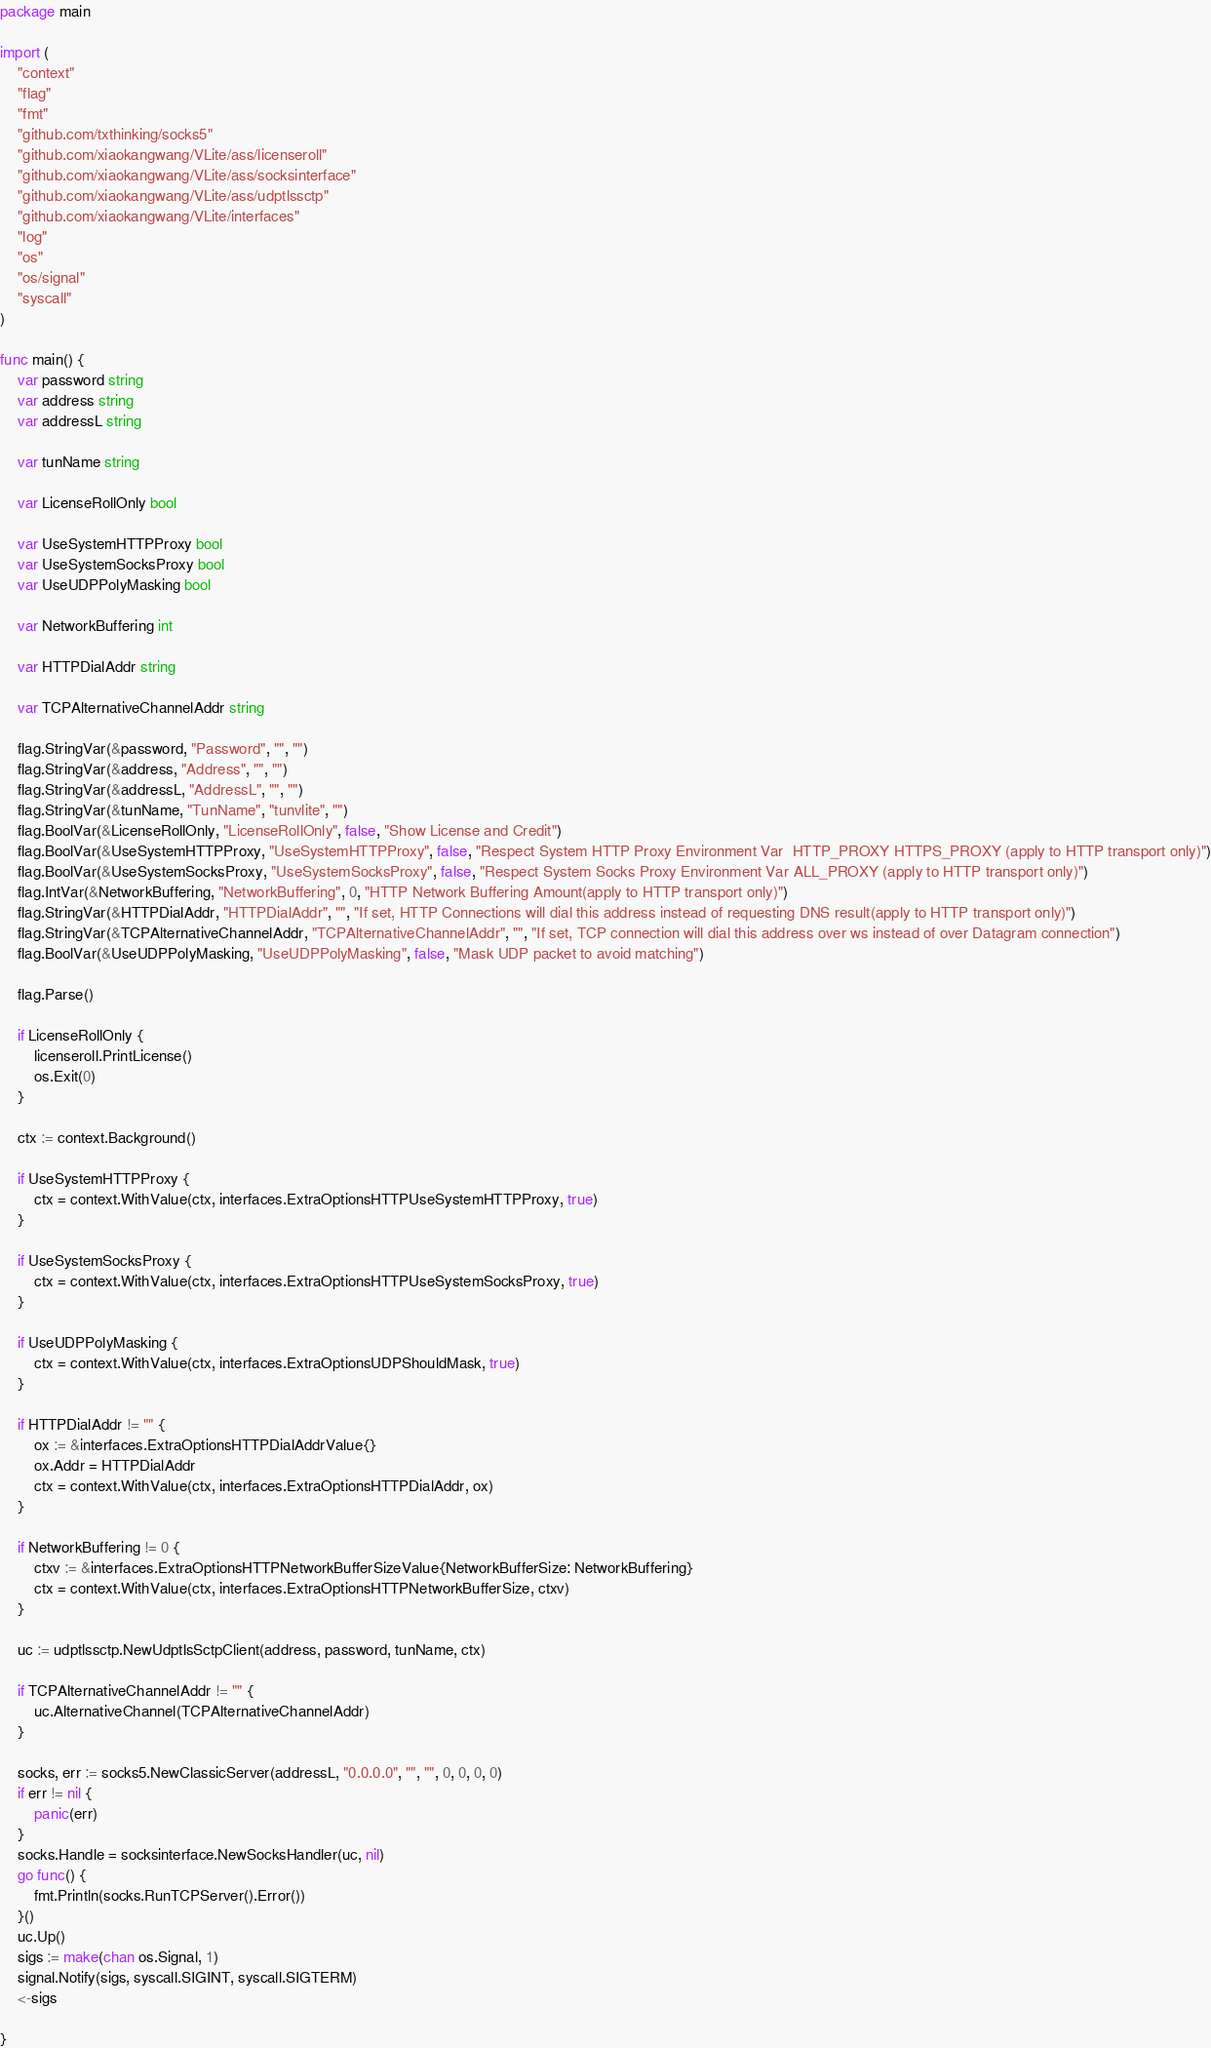<code> <loc_0><loc_0><loc_500><loc_500><_Go_>package main

import (
	"context"
	"flag"
	"fmt"
	"github.com/txthinking/socks5"
	"github.com/xiaokangwang/VLite/ass/licenseroll"
	"github.com/xiaokangwang/VLite/ass/socksinterface"
	"github.com/xiaokangwang/VLite/ass/udptlssctp"
	"github.com/xiaokangwang/VLite/interfaces"
	"log"
	"os"
	"os/signal"
	"syscall"
)

func main() {
	var password string
	var address string
	var addressL string

	var tunName string

	var LicenseRollOnly bool

	var UseSystemHTTPProxy bool
	var UseSystemSocksProxy bool
	var UseUDPPolyMasking bool

	var NetworkBuffering int

	var HTTPDialAddr string

	var TCPAlternativeChannelAddr string

	flag.StringVar(&password, "Password", "", "")
	flag.StringVar(&address, "Address", "", "")
	flag.StringVar(&addressL, "AddressL", "", "")
	flag.StringVar(&tunName, "TunName", "tunvlite", "")
	flag.BoolVar(&LicenseRollOnly, "LicenseRollOnly", false, "Show License and Credit")
	flag.BoolVar(&UseSystemHTTPProxy, "UseSystemHTTPProxy", false, "Respect System HTTP Proxy Environment Var  HTTP_PROXY HTTPS_PROXY (apply to HTTP transport only)")
	flag.BoolVar(&UseSystemSocksProxy, "UseSystemSocksProxy", false, "Respect System Socks Proxy Environment Var ALL_PROXY (apply to HTTP transport only)")
	flag.IntVar(&NetworkBuffering, "NetworkBuffering", 0, "HTTP Network Buffering Amount(apply to HTTP transport only)")
	flag.StringVar(&HTTPDialAddr, "HTTPDialAddr", "", "If set, HTTP Connections will dial this address instead of requesting DNS result(apply to HTTP transport only)")
	flag.StringVar(&TCPAlternativeChannelAddr, "TCPAlternativeChannelAddr", "", "If set, TCP connection will dial this address over ws instead of over Datagram connection")
	flag.BoolVar(&UseUDPPolyMasking, "UseUDPPolyMasking", false, "Mask UDP packet to avoid matching")

	flag.Parse()

	if LicenseRollOnly {
		licenseroll.PrintLicense()
		os.Exit(0)
	}

	ctx := context.Background()

	if UseSystemHTTPProxy {
		ctx = context.WithValue(ctx, interfaces.ExtraOptionsHTTPUseSystemHTTPProxy, true)
	}

	if UseSystemSocksProxy {
		ctx = context.WithValue(ctx, interfaces.ExtraOptionsHTTPUseSystemSocksProxy, true)
	}

	if UseUDPPolyMasking {
		ctx = context.WithValue(ctx, interfaces.ExtraOptionsUDPShouldMask, true)
	}

	if HTTPDialAddr != "" {
		ox := &interfaces.ExtraOptionsHTTPDialAddrValue{}
		ox.Addr = HTTPDialAddr
		ctx = context.WithValue(ctx, interfaces.ExtraOptionsHTTPDialAddr, ox)
	}

	if NetworkBuffering != 0 {
		ctxv := &interfaces.ExtraOptionsHTTPNetworkBufferSizeValue{NetworkBufferSize: NetworkBuffering}
		ctx = context.WithValue(ctx, interfaces.ExtraOptionsHTTPNetworkBufferSize, ctxv)
	}

	uc := udptlssctp.NewUdptlsSctpClient(address, password, tunName, ctx)

	if TCPAlternativeChannelAddr != "" {
		uc.AlternativeChannel(TCPAlternativeChannelAddr)
	}

	socks, err := socks5.NewClassicServer(addressL, "0.0.0.0", "", "", 0, 0, 0, 0)
	if err != nil {
		panic(err)
	}
	socks.Handle = socksinterface.NewSocksHandler(uc, nil)
	go func() {
		fmt.Println(socks.RunTCPServer().Error())
	}()
	uc.Up()
	sigs := make(chan os.Signal, 1)
	signal.Notify(sigs, syscall.SIGINT, syscall.SIGTERM)
	<-sigs

}
</code> 